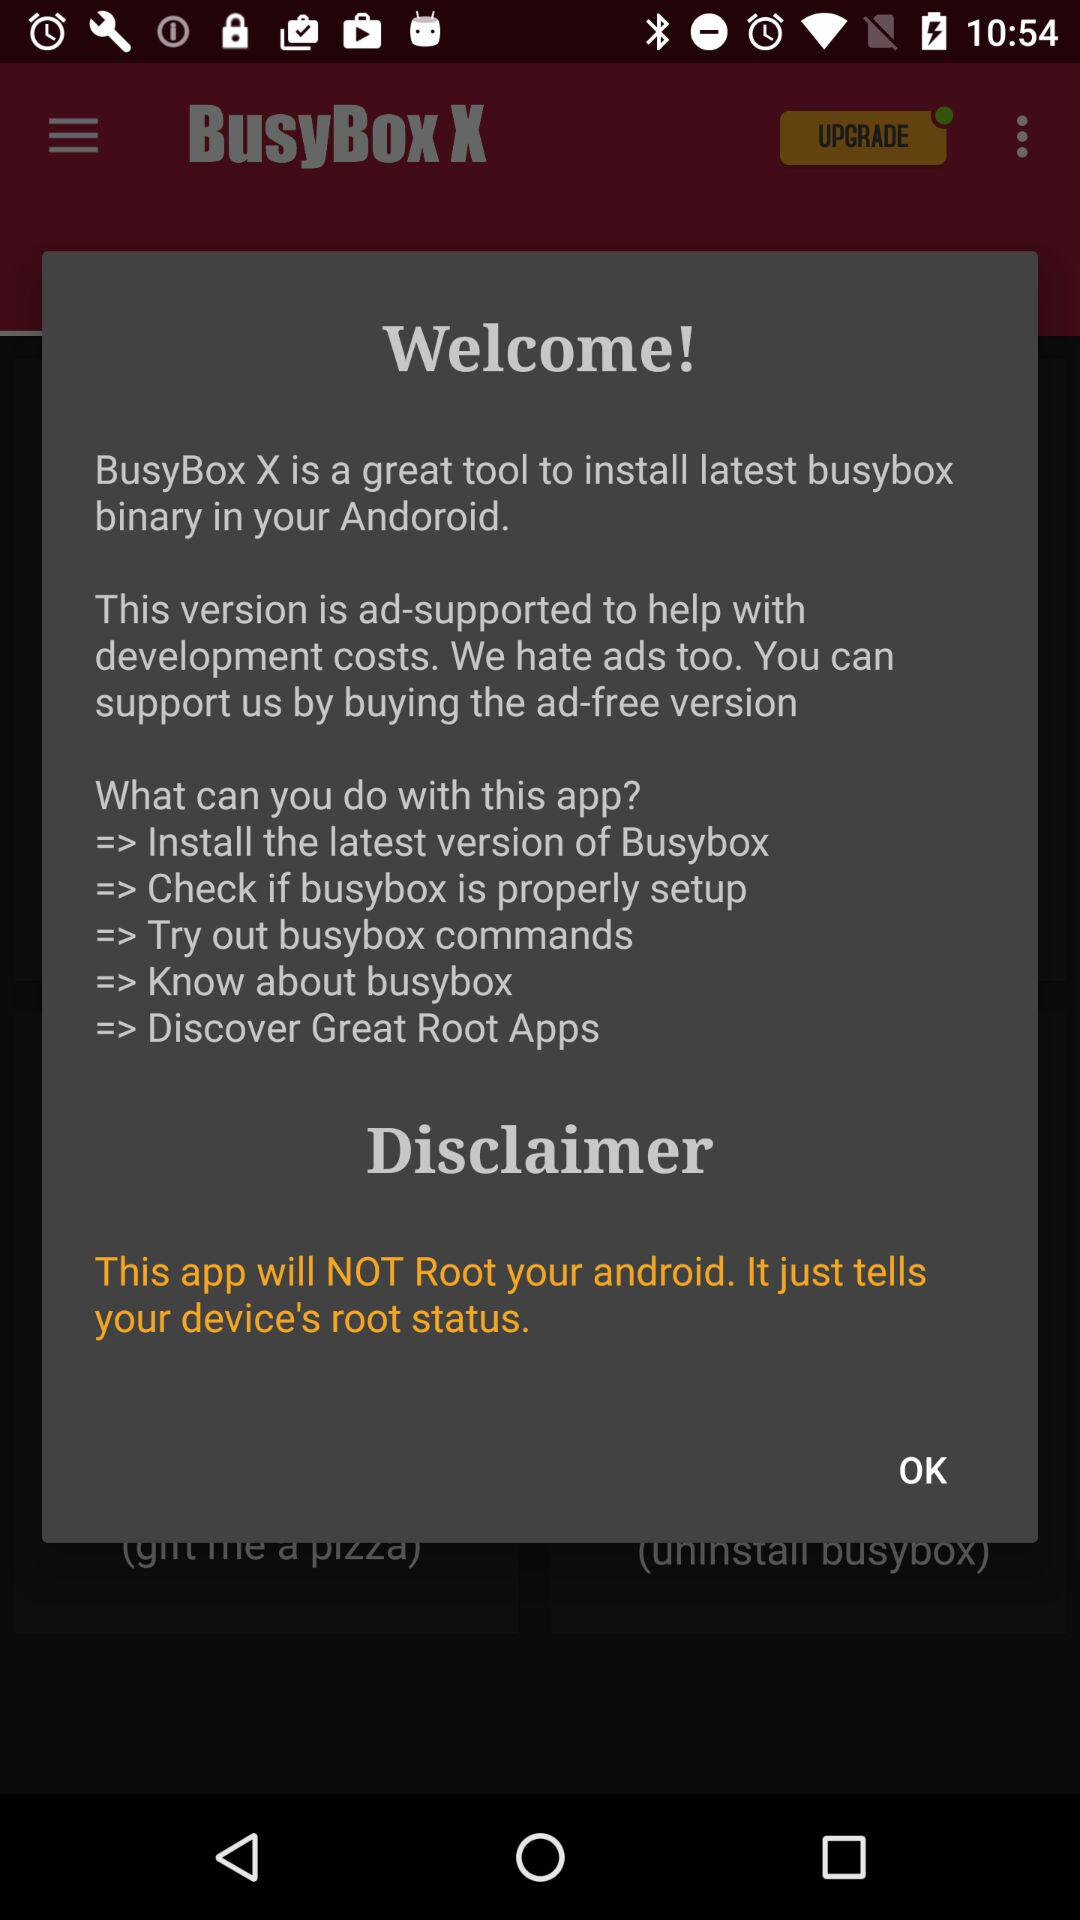How many different things can you do with this app?
Answer the question using a single word or phrase. 5 